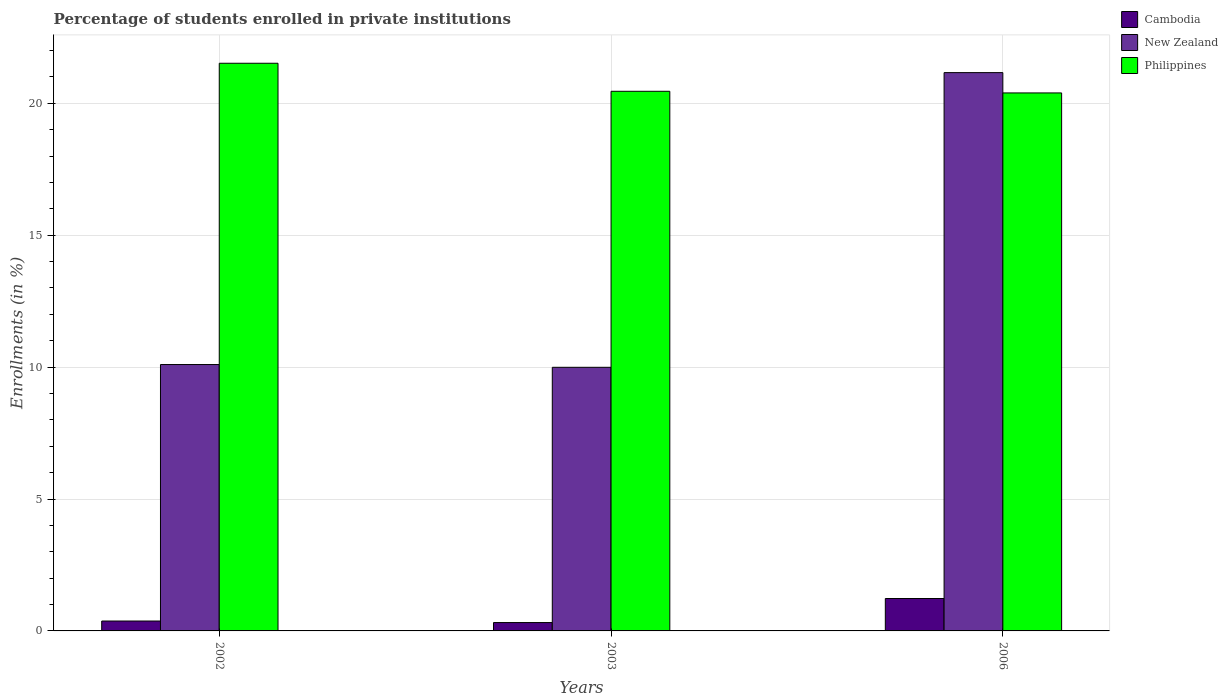How many bars are there on the 2nd tick from the left?
Offer a terse response. 3. What is the percentage of trained teachers in New Zealand in 2003?
Provide a succinct answer. 9.99. Across all years, what is the maximum percentage of trained teachers in Philippines?
Offer a very short reply. 21.52. Across all years, what is the minimum percentage of trained teachers in New Zealand?
Offer a very short reply. 9.99. What is the total percentage of trained teachers in Cambodia in the graph?
Your answer should be compact. 1.92. What is the difference between the percentage of trained teachers in Philippines in 2002 and that in 2006?
Offer a very short reply. 1.12. What is the difference between the percentage of trained teachers in New Zealand in 2003 and the percentage of trained teachers in Philippines in 2002?
Ensure brevity in your answer.  -11.52. What is the average percentage of trained teachers in Cambodia per year?
Offer a very short reply. 0.64. In the year 2002, what is the difference between the percentage of trained teachers in New Zealand and percentage of trained teachers in Cambodia?
Your response must be concise. 9.72. What is the ratio of the percentage of trained teachers in Cambodia in 2002 to that in 2006?
Ensure brevity in your answer.  0.31. Is the difference between the percentage of trained teachers in New Zealand in 2002 and 2003 greater than the difference between the percentage of trained teachers in Cambodia in 2002 and 2003?
Provide a succinct answer. Yes. What is the difference between the highest and the second highest percentage of trained teachers in Philippines?
Your response must be concise. 1.06. What is the difference between the highest and the lowest percentage of trained teachers in New Zealand?
Your response must be concise. 11.17. Is the sum of the percentage of trained teachers in New Zealand in 2003 and 2006 greater than the maximum percentage of trained teachers in Cambodia across all years?
Your answer should be very brief. Yes. What does the 2nd bar from the right in 2002 represents?
Your answer should be compact. New Zealand. How many bars are there?
Make the answer very short. 9. How many years are there in the graph?
Ensure brevity in your answer.  3. What is the difference between two consecutive major ticks on the Y-axis?
Your answer should be compact. 5. Are the values on the major ticks of Y-axis written in scientific E-notation?
Your answer should be very brief. No. Does the graph contain any zero values?
Ensure brevity in your answer.  No. What is the title of the graph?
Keep it short and to the point. Percentage of students enrolled in private institutions. Does "Niger" appear as one of the legend labels in the graph?
Ensure brevity in your answer.  No. What is the label or title of the X-axis?
Provide a succinct answer. Years. What is the label or title of the Y-axis?
Keep it short and to the point. Enrollments (in %). What is the Enrollments (in %) in Cambodia in 2002?
Your answer should be very brief. 0.38. What is the Enrollments (in %) in New Zealand in 2002?
Make the answer very short. 10.1. What is the Enrollments (in %) of Philippines in 2002?
Your response must be concise. 21.52. What is the Enrollments (in %) of Cambodia in 2003?
Your answer should be very brief. 0.32. What is the Enrollments (in %) in New Zealand in 2003?
Make the answer very short. 9.99. What is the Enrollments (in %) in Philippines in 2003?
Make the answer very short. 20.45. What is the Enrollments (in %) in Cambodia in 2006?
Your answer should be very brief. 1.23. What is the Enrollments (in %) in New Zealand in 2006?
Keep it short and to the point. 21.16. What is the Enrollments (in %) of Philippines in 2006?
Offer a very short reply. 20.39. Across all years, what is the maximum Enrollments (in %) of Cambodia?
Your answer should be very brief. 1.23. Across all years, what is the maximum Enrollments (in %) of New Zealand?
Ensure brevity in your answer.  21.16. Across all years, what is the maximum Enrollments (in %) of Philippines?
Provide a succinct answer. 21.52. Across all years, what is the minimum Enrollments (in %) of Cambodia?
Make the answer very short. 0.32. Across all years, what is the minimum Enrollments (in %) of New Zealand?
Provide a succinct answer. 9.99. Across all years, what is the minimum Enrollments (in %) in Philippines?
Provide a succinct answer. 20.39. What is the total Enrollments (in %) in Cambodia in the graph?
Offer a terse response. 1.92. What is the total Enrollments (in %) in New Zealand in the graph?
Your answer should be very brief. 41.25. What is the total Enrollments (in %) in Philippines in the graph?
Your answer should be compact. 62.36. What is the difference between the Enrollments (in %) of Cambodia in 2002 and that in 2003?
Offer a terse response. 0.06. What is the difference between the Enrollments (in %) of New Zealand in 2002 and that in 2003?
Your response must be concise. 0.1. What is the difference between the Enrollments (in %) of Philippines in 2002 and that in 2003?
Keep it short and to the point. 1.06. What is the difference between the Enrollments (in %) in Cambodia in 2002 and that in 2006?
Your response must be concise. -0.85. What is the difference between the Enrollments (in %) in New Zealand in 2002 and that in 2006?
Your response must be concise. -11.07. What is the difference between the Enrollments (in %) in Philippines in 2002 and that in 2006?
Make the answer very short. 1.12. What is the difference between the Enrollments (in %) in Cambodia in 2003 and that in 2006?
Your answer should be very brief. -0.91. What is the difference between the Enrollments (in %) in New Zealand in 2003 and that in 2006?
Your answer should be compact. -11.17. What is the difference between the Enrollments (in %) of Philippines in 2003 and that in 2006?
Provide a short and direct response. 0.06. What is the difference between the Enrollments (in %) of Cambodia in 2002 and the Enrollments (in %) of New Zealand in 2003?
Provide a short and direct response. -9.62. What is the difference between the Enrollments (in %) in Cambodia in 2002 and the Enrollments (in %) in Philippines in 2003?
Your response must be concise. -20.08. What is the difference between the Enrollments (in %) in New Zealand in 2002 and the Enrollments (in %) in Philippines in 2003?
Give a very brief answer. -10.36. What is the difference between the Enrollments (in %) of Cambodia in 2002 and the Enrollments (in %) of New Zealand in 2006?
Ensure brevity in your answer.  -20.79. What is the difference between the Enrollments (in %) of Cambodia in 2002 and the Enrollments (in %) of Philippines in 2006?
Offer a very short reply. -20.02. What is the difference between the Enrollments (in %) of New Zealand in 2002 and the Enrollments (in %) of Philippines in 2006?
Offer a very short reply. -10.3. What is the difference between the Enrollments (in %) in Cambodia in 2003 and the Enrollments (in %) in New Zealand in 2006?
Provide a succinct answer. -20.85. What is the difference between the Enrollments (in %) in Cambodia in 2003 and the Enrollments (in %) in Philippines in 2006?
Give a very brief answer. -20.08. What is the difference between the Enrollments (in %) in New Zealand in 2003 and the Enrollments (in %) in Philippines in 2006?
Give a very brief answer. -10.4. What is the average Enrollments (in %) in Cambodia per year?
Your response must be concise. 0.64. What is the average Enrollments (in %) in New Zealand per year?
Keep it short and to the point. 13.75. What is the average Enrollments (in %) in Philippines per year?
Offer a very short reply. 20.79. In the year 2002, what is the difference between the Enrollments (in %) of Cambodia and Enrollments (in %) of New Zealand?
Make the answer very short. -9.72. In the year 2002, what is the difference between the Enrollments (in %) of Cambodia and Enrollments (in %) of Philippines?
Your answer should be very brief. -21.14. In the year 2002, what is the difference between the Enrollments (in %) of New Zealand and Enrollments (in %) of Philippines?
Give a very brief answer. -11.42. In the year 2003, what is the difference between the Enrollments (in %) of Cambodia and Enrollments (in %) of New Zealand?
Your answer should be very brief. -9.68. In the year 2003, what is the difference between the Enrollments (in %) in Cambodia and Enrollments (in %) in Philippines?
Your response must be concise. -20.14. In the year 2003, what is the difference between the Enrollments (in %) in New Zealand and Enrollments (in %) in Philippines?
Offer a very short reply. -10.46. In the year 2006, what is the difference between the Enrollments (in %) of Cambodia and Enrollments (in %) of New Zealand?
Your answer should be compact. -19.93. In the year 2006, what is the difference between the Enrollments (in %) of Cambodia and Enrollments (in %) of Philippines?
Offer a terse response. -19.16. In the year 2006, what is the difference between the Enrollments (in %) of New Zealand and Enrollments (in %) of Philippines?
Your response must be concise. 0.77. What is the ratio of the Enrollments (in %) in Cambodia in 2002 to that in 2003?
Provide a short and direct response. 1.18. What is the ratio of the Enrollments (in %) in New Zealand in 2002 to that in 2003?
Provide a succinct answer. 1.01. What is the ratio of the Enrollments (in %) of Philippines in 2002 to that in 2003?
Provide a short and direct response. 1.05. What is the ratio of the Enrollments (in %) in Cambodia in 2002 to that in 2006?
Your answer should be compact. 0.31. What is the ratio of the Enrollments (in %) of New Zealand in 2002 to that in 2006?
Your response must be concise. 0.48. What is the ratio of the Enrollments (in %) in Philippines in 2002 to that in 2006?
Your answer should be very brief. 1.06. What is the ratio of the Enrollments (in %) in Cambodia in 2003 to that in 2006?
Ensure brevity in your answer.  0.26. What is the ratio of the Enrollments (in %) in New Zealand in 2003 to that in 2006?
Your response must be concise. 0.47. What is the difference between the highest and the second highest Enrollments (in %) of Cambodia?
Offer a very short reply. 0.85. What is the difference between the highest and the second highest Enrollments (in %) of New Zealand?
Offer a terse response. 11.07. What is the difference between the highest and the second highest Enrollments (in %) in Philippines?
Your answer should be very brief. 1.06. What is the difference between the highest and the lowest Enrollments (in %) of Cambodia?
Your response must be concise. 0.91. What is the difference between the highest and the lowest Enrollments (in %) in New Zealand?
Keep it short and to the point. 11.17. What is the difference between the highest and the lowest Enrollments (in %) in Philippines?
Provide a short and direct response. 1.12. 